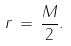Convert formula to latex. <formula><loc_0><loc_0><loc_500><loc_500>{ r } \, = \, \frac { M } { 2 } .</formula> 